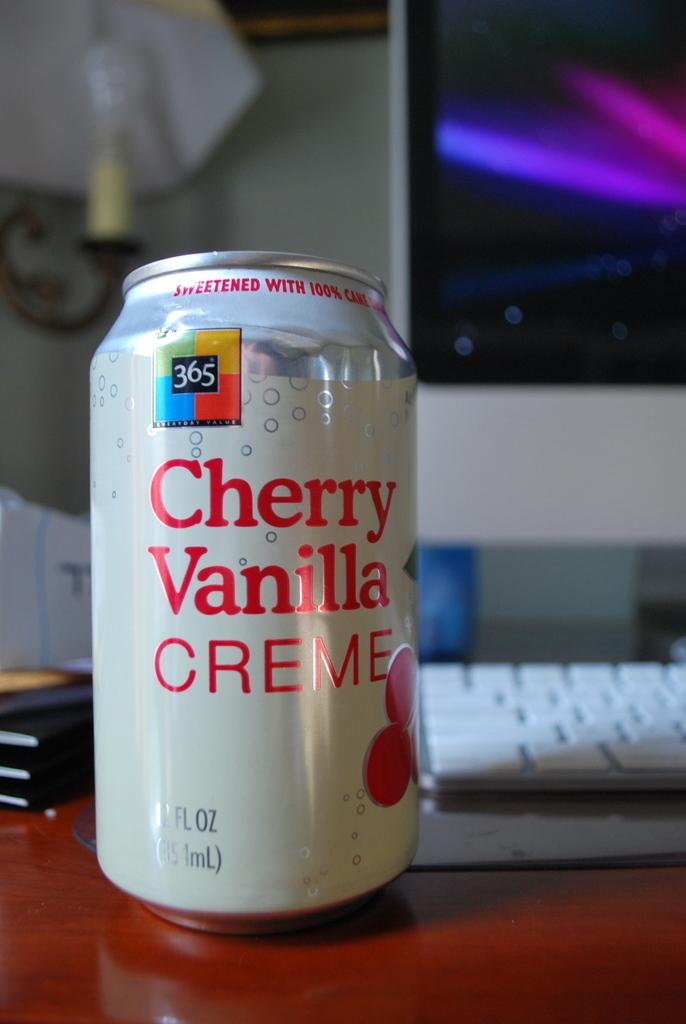<image>
Render a clear and concise summary of the photo. A can of cherry vanilla creme soda sits on a desk next to a computer. 